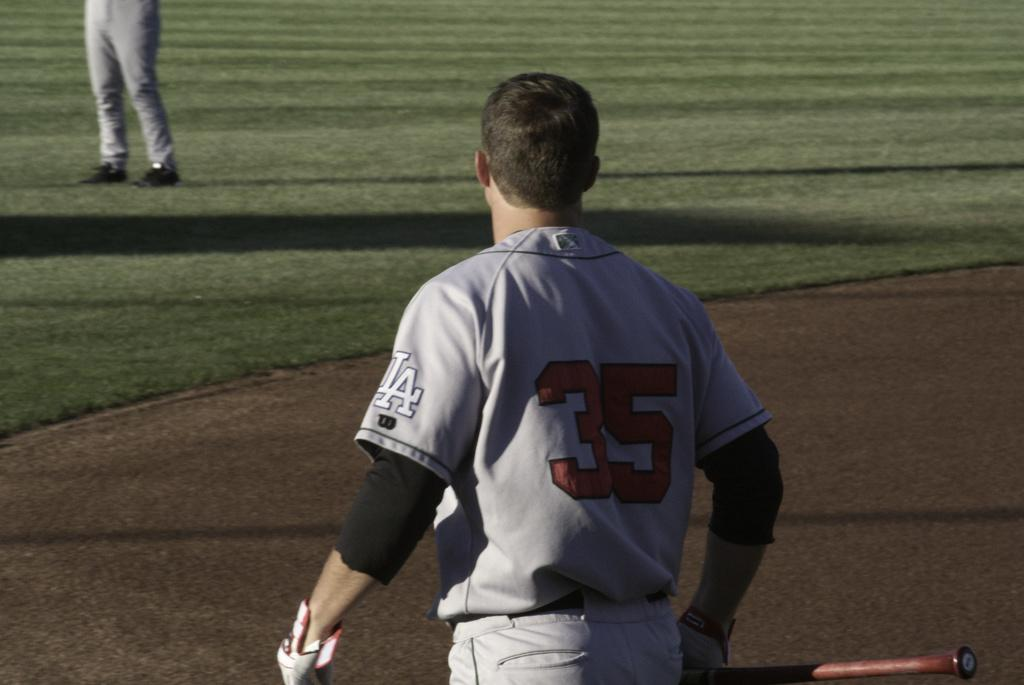Provide a one-sentence caption for the provided image. Number 35 for L.A. is holding a bat in his right hand. 